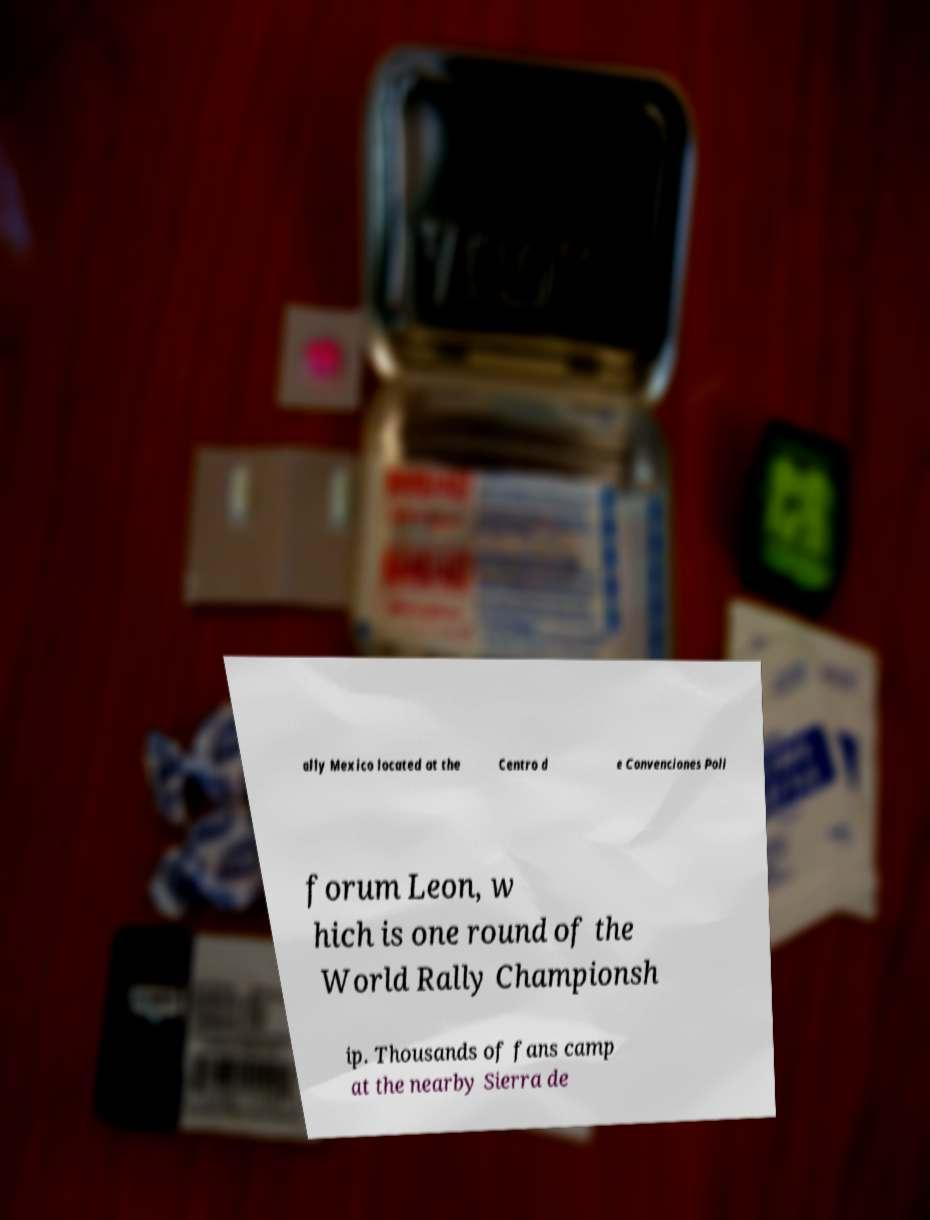There's text embedded in this image that I need extracted. Can you transcribe it verbatim? ally Mexico located at the Centro d e Convenciones Poli forum Leon, w hich is one round of the World Rally Championsh ip. Thousands of fans camp at the nearby Sierra de 